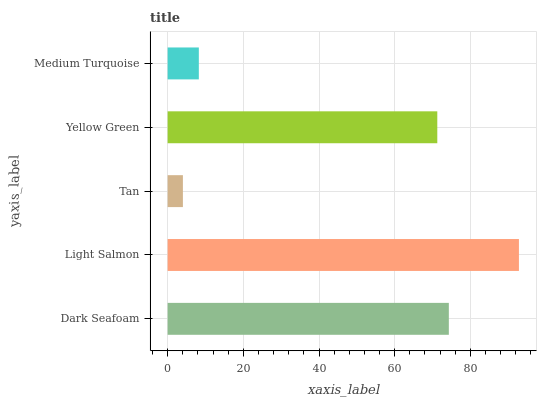Is Tan the minimum?
Answer yes or no. Yes. Is Light Salmon the maximum?
Answer yes or no. Yes. Is Light Salmon the minimum?
Answer yes or no. No. Is Tan the maximum?
Answer yes or no. No. Is Light Salmon greater than Tan?
Answer yes or no. Yes. Is Tan less than Light Salmon?
Answer yes or no. Yes. Is Tan greater than Light Salmon?
Answer yes or no. No. Is Light Salmon less than Tan?
Answer yes or no. No. Is Yellow Green the high median?
Answer yes or no. Yes. Is Yellow Green the low median?
Answer yes or no. Yes. Is Tan the high median?
Answer yes or no. No. Is Dark Seafoam the low median?
Answer yes or no. No. 